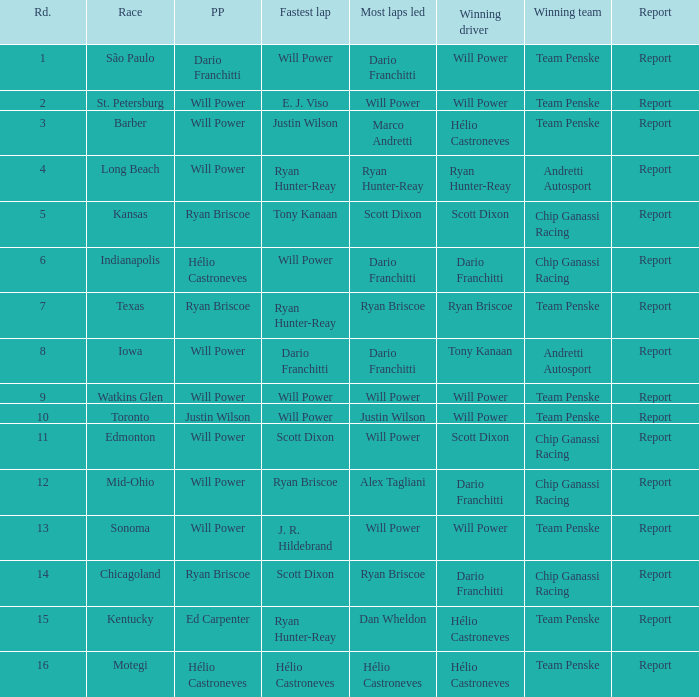In what position did the winning driver finish at Chicagoland? 1.0. 